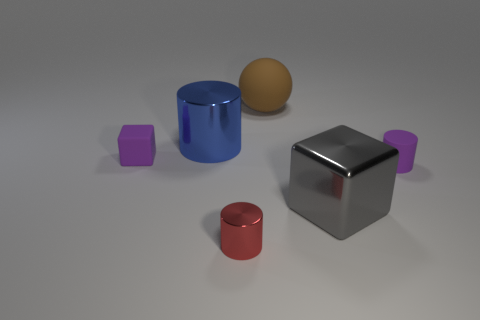Subtract all green cylinders. Subtract all blue spheres. How many cylinders are left? 3 Add 2 large objects. How many objects exist? 8 Subtract all blocks. How many objects are left? 4 Add 3 rubber things. How many rubber things exist? 6 Subtract 0 green spheres. How many objects are left? 6 Subtract all green rubber cylinders. Subtract all brown matte things. How many objects are left? 5 Add 5 tiny purple rubber objects. How many tiny purple rubber objects are left? 7 